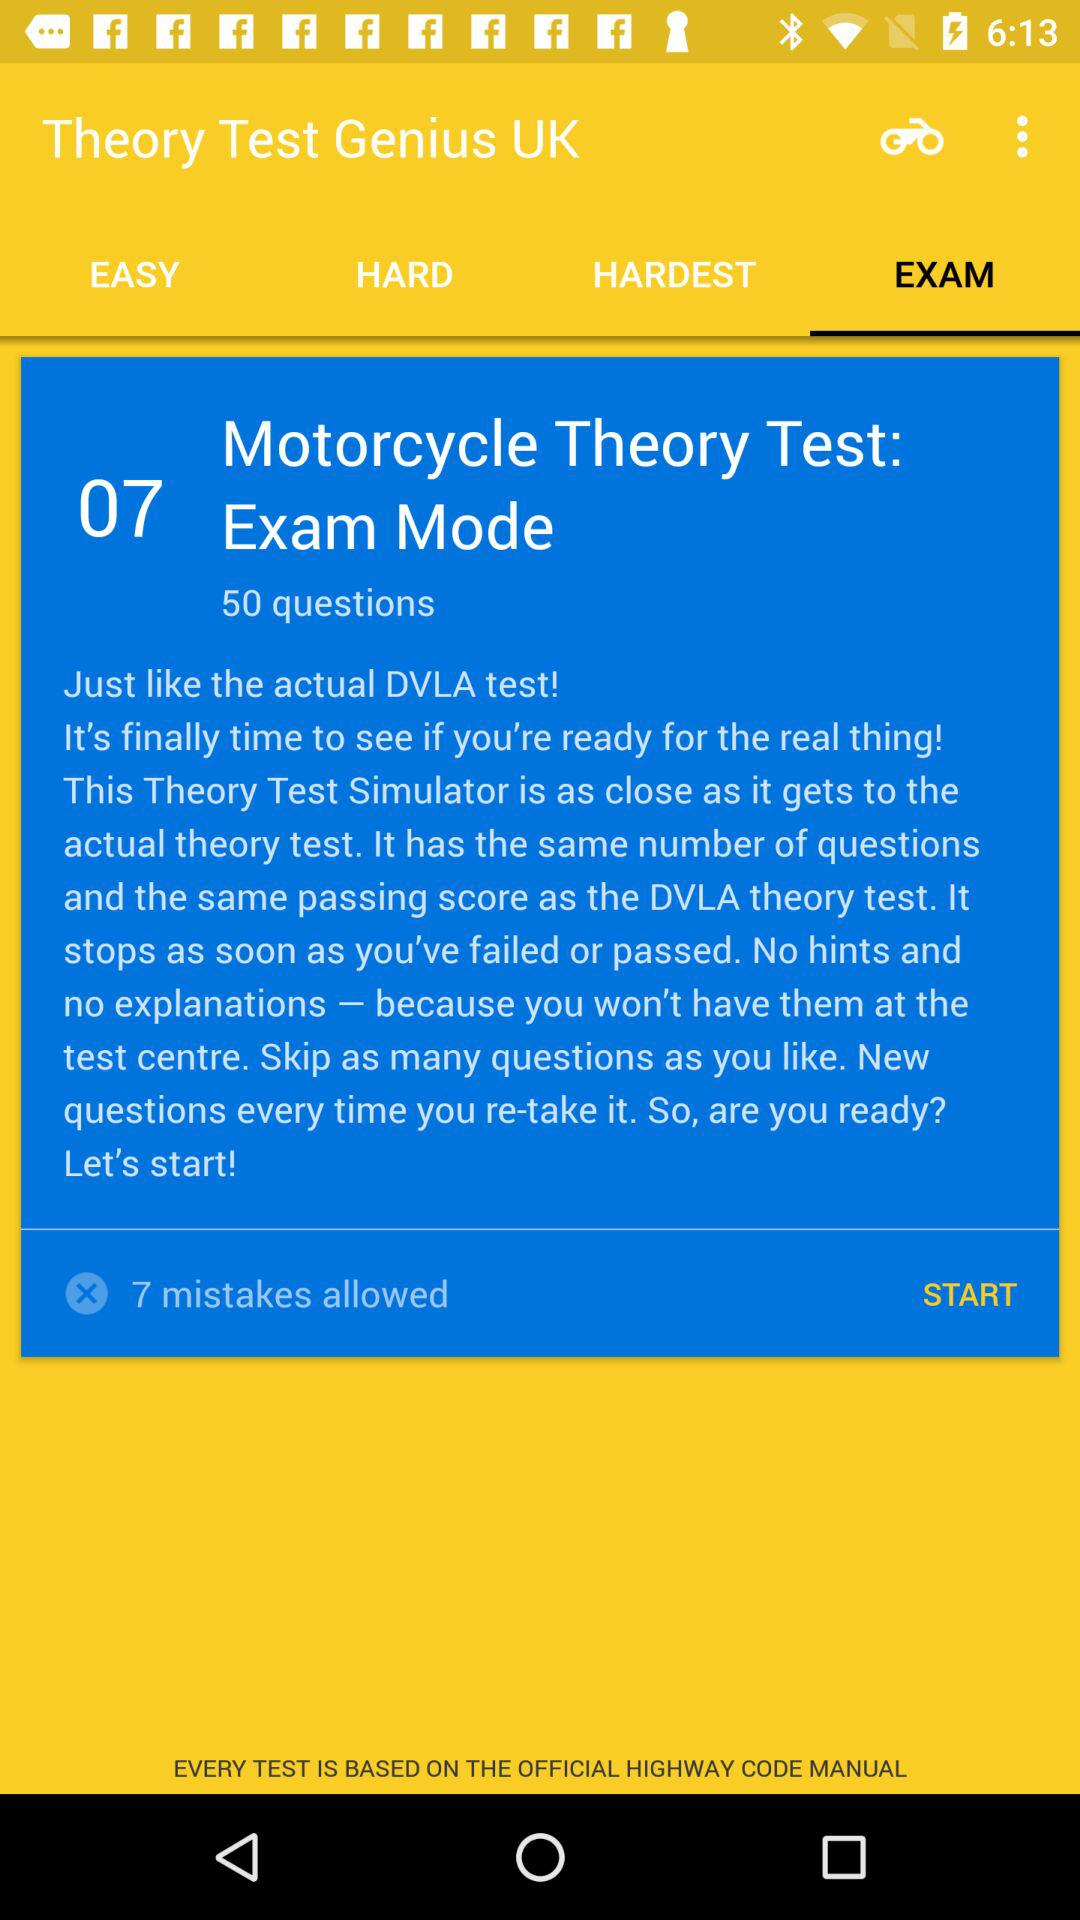How many questions are there in "Motorcycle Theory"? There are 50 questions in "Motorcycle Theory". 